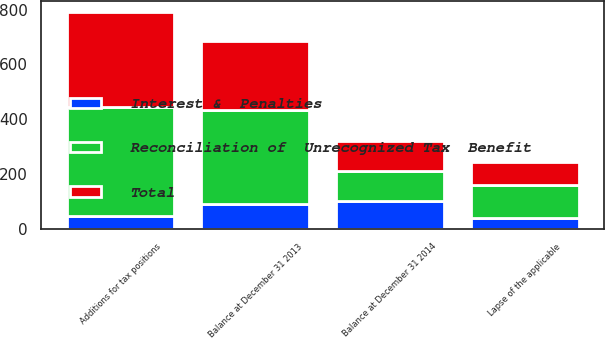<chart> <loc_0><loc_0><loc_500><loc_500><stacked_bar_chart><ecel><fcel>Balance at December 31 2013<fcel>Additions for tax positions<fcel>Lapse of the applicable<fcel>Balance at December 31 2014<nl><fcel>Total<fcel>252<fcel>349<fcel>83<fcel>110.5<nl><fcel>Interest &  Penalties<fcel>91<fcel>47<fcel>38<fcel>100<nl><fcel>Reconciliation of  Unrecognized Tax  Benefit<fcel>343<fcel>396<fcel>121<fcel>110.5<nl></chart> 